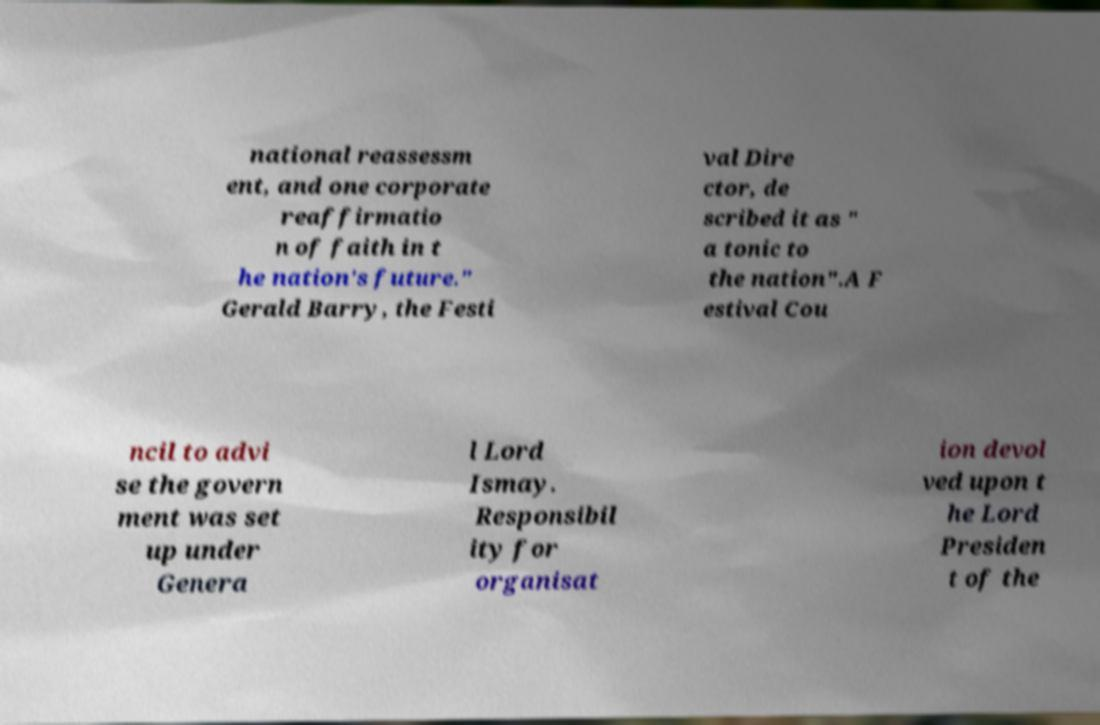Could you assist in decoding the text presented in this image and type it out clearly? national reassessm ent, and one corporate reaffirmatio n of faith in t he nation's future." Gerald Barry, the Festi val Dire ctor, de scribed it as " a tonic to the nation".A F estival Cou ncil to advi se the govern ment was set up under Genera l Lord Ismay. Responsibil ity for organisat ion devol ved upon t he Lord Presiden t of the 